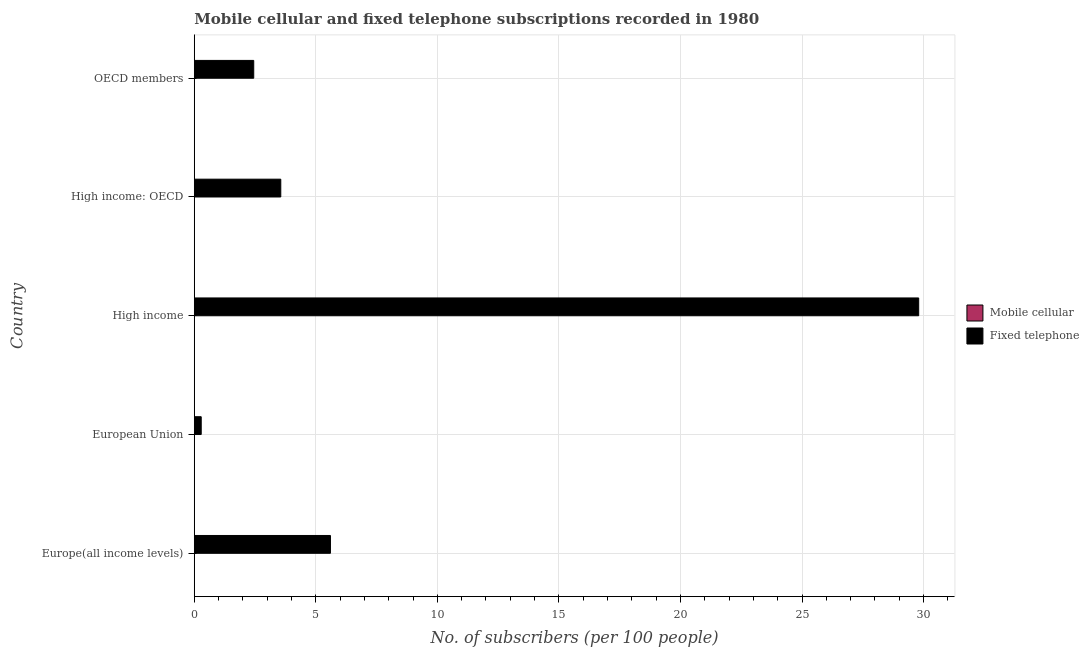How many different coloured bars are there?
Keep it short and to the point. 2. How many groups of bars are there?
Offer a terse response. 5. Are the number of bars per tick equal to the number of legend labels?
Keep it short and to the point. Yes. How many bars are there on the 3rd tick from the bottom?
Your answer should be compact. 2. What is the label of the 5th group of bars from the top?
Give a very brief answer. Europe(all income levels). What is the number of fixed telephone subscribers in High income: OECD?
Your answer should be compact. 3.56. Across all countries, what is the maximum number of mobile cellular subscribers?
Ensure brevity in your answer.  0.01. Across all countries, what is the minimum number of mobile cellular subscribers?
Ensure brevity in your answer.  0. In which country was the number of mobile cellular subscribers maximum?
Offer a very short reply. European Union. In which country was the number of fixed telephone subscribers minimum?
Your answer should be very brief. European Union. What is the total number of fixed telephone subscribers in the graph?
Your answer should be very brief. 41.69. What is the difference between the number of mobile cellular subscribers in European Union and that in OECD members?
Ensure brevity in your answer.  0. What is the difference between the number of mobile cellular subscribers in OECD members and the number of fixed telephone subscribers in European Union?
Make the answer very short. -0.28. What is the average number of fixed telephone subscribers per country?
Make the answer very short. 8.34. What is the difference between the number of mobile cellular subscribers and number of fixed telephone subscribers in High income?
Make the answer very short. -29.8. In how many countries, is the number of mobile cellular subscribers greater than 30 ?
Ensure brevity in your answer.  0. What is the ratio of the number of mobile cellular subscribers in European Union to that in High income: OECD?
Give a very brief answer. 1.87. Is the number of mobile cellular subscribers in European Union less than that in High income: OECD?
Your answer should be very brief. No. What is the difference between the highest and the second highest number of mobile cellular subscribers?
Ensure brevity in your answer.  0. What is the difference between the highest and the lowest number of fixed telephone subscribers?
Make the answer very short. 29.51. In how many countries, is the number of fixed telephone subscribers greater than the average number of fixed telephone subscribers taken over all countries?
Provide a short and direct response. 1. Is the sum of the number of fixed telephone subscribers in High income and High income: OECD greater than the maximum number of mobile cellular subscribers across all countries?
Offer a very short reply. Yes. What does the 1st bar from the top in OECD members represents?
Give a very brief answer. Fixed telephone. What does the 2nd bar from the bottom in High income: OECD represents?
Make the answer very short. Fixed telephone. How many countries are there in the graph?
Your answer should be compact. 5. Are the values on the major ticks of X-axis written in scientific E-notation?
Provide a short and direct response. No. Where does the legend appear in the graph?
Offer a very short reply. Center right. How many legend labels are there?
Offer a very short reply. 2. How are the legend labels stacked?
Offer a terse response. Vertical. What is the title of the graph?
Ensure brevity in your answer.  Mobile cellular and fixed telephone subscriptions recorded in 1980. Does "current US$" appear as one of the legend labels in the graph?
Provide a short and direct response. No. What is the label or title of the X-axis?
Keep it short and to the point. No. of subscribers (per 100 people). What is the label or title of the Y-axis?
Your response must be concise. Country. What is the No. of subscribers (per 100 people) in Mobile cellular in Europe(all income levels)?
Ensure brevity in your answer.  0. What is the No. of subscribers (per 100 people) of Fixed telephone in Europe(all income levels)?
Ensure brevity in your answer.  5.6. What is the No. of subscribers (per 100 people) in Mobile cellular in European Union?
Offer a terse response. 0.01. What is the No. of subscribers (per 100 people) in Fixed telephone in European Union?
Keep it short and to the point. 0.29. What is the No. of subscribers (per 100 people) in Mobile cellular in High income?
Offer a very short reply. 0. What is the No. of subscribers (per 100 people) in Fixed telephone in High income?
Provide a succinct answer. 29.8. What is the No. of subscribers (per 100 people) of Mobile cellular in High income: OECD?
Your answer should be compact. 0. What is the No. of subscribers (per 100 people) of Fixed telephone in High income: OECD?
Make the answer very short. 3.56. What is the No. of subscribers (per 100 people) in Mobile cellular in OECD members?
Give a very brief answer. 0. What is the No. of subscribers (per 100 people) of Fixed telephone in OECD members?
Provide a succinct answer. 2.45. Across all countries, what is the maximum No. of subscribers (per 100 people) in Mobile cellular?
Your answer should be very brief. 0.01. Across all countries, what is the maximum No. of subscribers (per 100 people) in Fixed telephone?
Ensure brevity in your answer.  29.8. Across all countries, what is the minimum No. of subscribers (per 100 people) in Mobile cellular?
Your answer should be compact. 0. Across all countries, what is the minimum No. of subscribers (per 100 people) in Fixed telephone?
Your answer should be compact. 0.29. What is the total No. of subscribers (per 100 people) in Mobile cellular in the graph?
Provide a short and direct response. 0.02. What is the total No. of subscribers (per 100 people) in Fixed telephone in the graph?
Offer a terse response. 41.69. What is the difference between the No. of subscribers (per 100 people) in Mobile cellular in Europe(all income levels) and that in European Union?
Offer a very short reply. -0. What is the difference between the No. of subscribers (per 100 people) in Fixed telephone in Europe(all income levels) and that in European Union?
Offer a very short reply. 5.32. What is the difference between the No. of subscribers (per 100 people) in Mobile cellular in Europe(all income levels) and that in High income?
Provide a succinct answer. 0. What is the difference between the No. of subscribers (per 100 people) in Fixed telephone in Europe(all income levels) and that in High income?
Provide a short and direct response. -24.2. What is the difference between the No. of subscribers (per 100 people) in Fixed telephone in Europe(all income levels) and that in High income: OECD?
Ensure brevity in your answer.  2.04. What is the difference between the No. of subscribers (per 100 people) of Mobile cellular in Europe(all income levels) and that in OECD members?
Your answer should be very brief. 0. What is the difference between the No. of subscribers (per 100 people) of Fixed telephone in Europe(all income levels) and that in OECD members?
Offer a very short reply. 3.16. What is the difference between the No. of subscribers (per 100 people) of Mobile cellular in European Union and that in High income?
Ensure brevity in your answer.  0. What is the difference between the No. of subscribers (per 100 people) of Fixed telephone in European Union and that in High income?
Offer a very short reply. -29.51. What is the difference between the No. of subscribers (per 100 people) of Mobile cellular in European Union and that in High income: OECD?
Offer a very short reply. 0. What is the difference between the No. of subscribers (per 100 people) in Fixed telephone in European Union and that in High income: OECD?
Ensure brevity in your answer.  -3.27. What is the difference between the No. of subscribers (per 100 people) of Mobile cellular in European Union and that in OECD members?
Ensure brevity in your answer.  0. What is the difference between the No. of subscribers (per 100 people) in Fixed telephone in European Union and that in OECD members?
Offer a terse response. -2.16. What is the difference between the No. of subscribers (per 100 people) of Mobile cellular in High income and that in High income: OECD?
Your answer should be compact. -0. What is the difference between the No. of subscribers (per 100 people) in Fixed telephone in High income and that in High income: OECD?
Provide a succinct answer. 26.24. What is the difference between the No. of subscribers (per 100 people) in Mobile cellular in High income and that in OECD members?
Provide a succinct answer. -0. What is the difference between the No. of subscribers (per 100 people) of Fixed telephone in High income and that in OECD members?
Your answer should be compact. 27.35. What is the difference between the No. of subscribers (per 100 people) in Fixed telephone in High income: OECD and that in OECD members?
Provide a succinct answer. 1.11. What is the difference between the No. of subscribers (per 100 people) of Mobile cellular in Europe(all income levels) and the No. of subscribers (per 100 people) of Fixed telephone in European Union?
Give a very brief answer. -0.28. What is the difference between the No. of subscribers (per 100 people) of Mobile cellular in Europe(all income levels) and the No. of subscribers (per 100 people) of Fixed telephone in High income?
Your answer should be very brief. -29.8. What is the difference between the No. of subscribers (per 100 people) in Mobile cellular in Europe(all income levels) and the No. of subscribers (per 100 people) in Fixed telephone in High income: OECD?
Provide a succinct answer. -3.56. What is the difference between the No. of subscribers (per 100 people) of Mobile cellular in Europe(all income levels) and the No. of subscribers (per 100 people) of Fixed telephone in OECD members?
Keep it short and to the point. -2.44. What is the difference between the No. of subscribers (per 100 people) of Mobile cellular in European Union and the No. of subscribers (per 100 people) of Fixed telephone in High income?
Offer a very short reply. -29.79. What is the difference between the No. of subscribers (per 100 people) of Mobile cellular in European Union and the No. of subscribers (per 100 people) of Fixed telephone in High income: OECD?
Provide a short and direct response. -3.55. What is the difference between the No. of subscribers (per 100 people) in Mobile cellular in European Union and the No. of subscribers (per 100 people) in Fixed telephone in OECD members?
Make the answer very short. -2.44. What is the difference between the No. of subscribers (per 100 people) of Mobile cellular in High income and the No. of subscribers (per 100 people) of Fixed telephone in High income: OECD?
Your response must be concise. -3.56. What is the difference between the No. of subscribers (per 100 people) of Mobile cellular in High income and the No. of subscribers (per 100 people) of Fixed telephone in OECD members?
Provide a succinct answer. -2.44. What is the difference between the No. of subscribers (per 100 people) in Mobile cellular in High income: OECD and the No. of subscribers (per 100 people) in Fixed telephone in OECD members?
Offer a terse response. -2.44. What is the average No. of subscribers (per 100 people) of Mobile cellular per country?
Offer a terse response. 0. What is the average No. of subscribers (per 100 people) of Fixed telephone per country?
Provide a succinct answer. 8.34. What is the difference between the No. of subscribers (per 100 people) in Mobile cellular and No. of subscribers (per 100 people) in Fixed telephone in Europe(all income levels)?
Keep it short and to the point. -5.6. What is the difference between the No. of subscribers (per 100 people) of Mobile cellular and No. of subscribers (per 100 people) of Fixed telephone in European Union?
Give a very brief answer. -0.28. What is the difference between the No. of subscribers (per 100 people) of Mobile cellular and No. of subscribers (per 100 people) of Fixed telephone in High income?
Keep it short and to the point. -29.8. What is the difference between the No. of subscribers (per 100 people) of Mobile cellular and No. of subscribers (per 100 people) of Fixed telephone in High income: OECD?
Provide a short and direct response. -3.56. What is the difference between the No. of subscribers (per 100 people) of Mobile cellular and No. of subscribers (per 100 people) of Fixed telephone in OECD members?
Give a very brief answer. -2.44. What is the ratio of the No. of subscribers (per 100 people) of Mobile cellular in Europe(all income levels) to that in European Union?
Give a very brief answer. 0.59. What is the ratio of the No. of subscribers (per 100 people) in Fixed telephone in Europe(all income levels) to that in European Union?
Your answer should be compact. 19.58. What is the ratio of the No. of subscribers (per 100 people) of Mobile cellular in Europe(all income levels) to that in High income?
Keep it short and to the point. 1.4. What is the ratio of the No. of subscribers (per 100 people) of Fixed telephone in Europe(all income levels) to that in High income?
Make the answer very short. 0.19. What is the ratio of the No. of subscribers (per 100 people) of Mobile cellular in Europe(all income levels) to that in High income: OECD?
Keep it short and to the point. 1.11. What is the ratio of the No. of subscribers (per 100 people) in Fixed telephone in Europe(all income levels) to that in High income: OECD?
Your response must be concise. 1.57. What is the ratio of the No. of subscribers (per 100 people) in Mobile cellular in Europe(all income levels) to that in OECD members?
Keep it short and to the point. 1.25. What is the ratio of the No. of subscribers (per 100 people) of Fixed telephone in Europe(all income levels) to that in OECD members?
Your response must be concise. 2.29. What is the ratio of the No. of subscribers (per 100 people) of Mobile cellular in European Union to that in High income?
Offer a terse response. 2.37. What is the ratio of the No. of subscribers (per 100 people) in Fixed telephone in European Union to that in High income?
Your answer should be very brief. 0.01. What is the ratio of the No. of subscribers (per 100 people) of Mobile cellular in European Union to that in High income: OECD?
Make the answer very short. 1.87. What is the ratio of the No. of subscribers (per 100 people) of Fixed telephone in European Union to that in High income: OECD?
Offer a very short reply. 0.08. What is the ratio of the No. of subscribers (per 100 people) in Mobile cellular in European Union to that in OECD members?
Your answer should be very brief. 2.12. What is the ratio of the No. of subscribers (per 100 people) of Fixed telephone in European Union to that in OECD members?
Your response must be concise. 0.12. What is the ratio of the No. of subscribers (per 100 people) of Mobile cellular in High income to that in High income: OECD?
Offer a terse response. 0.79. What is the ratio of the No. of subscribers (per 100 people) in Fixed telephone in High income to that in High income: OECD?
Offer a very short reply. 8.37. What is the ratio of the No. of subscribers (per 100 people) in Mobile cellular in High income to that in OECD members?
Ensure brevity in your answer.  0.89. What is the ratio of the No. of subscribers (per 100 people) in Fixed telephone in High income to that in OECD members?
Keep it short and to the point. 12.18. What is the ratio of the No. of subscribers (per 100 people) of Mobile cellular in High income: OECD to that in OECD members?
Keep it short and to the point. 1.13. What is the ratio of the No. of subscribers (per 100 people) in Fixed telephone in High income: OECD to that in OECD members?
Offer a very short reply. 1.46. What is the difference between the highest and the second highest No. of subscribers (per 100 people) of Mobile cellular?
Your answer should be very brief. 0. What is the difference between the highest and the second highest No. of subscribers (per 100 people) in Fixed telephone?
Offer a very short reply. 24.2. What is the difference between the highest and the lowest No. of subscribers (per 100 people) of Mobile cellular?
Provide a succinct answer. 0. What is the difference between the highest and the lowest No. of subscribers (per 100 people) in Fixed telephone?
Provide a succinct answer. 29.51. 